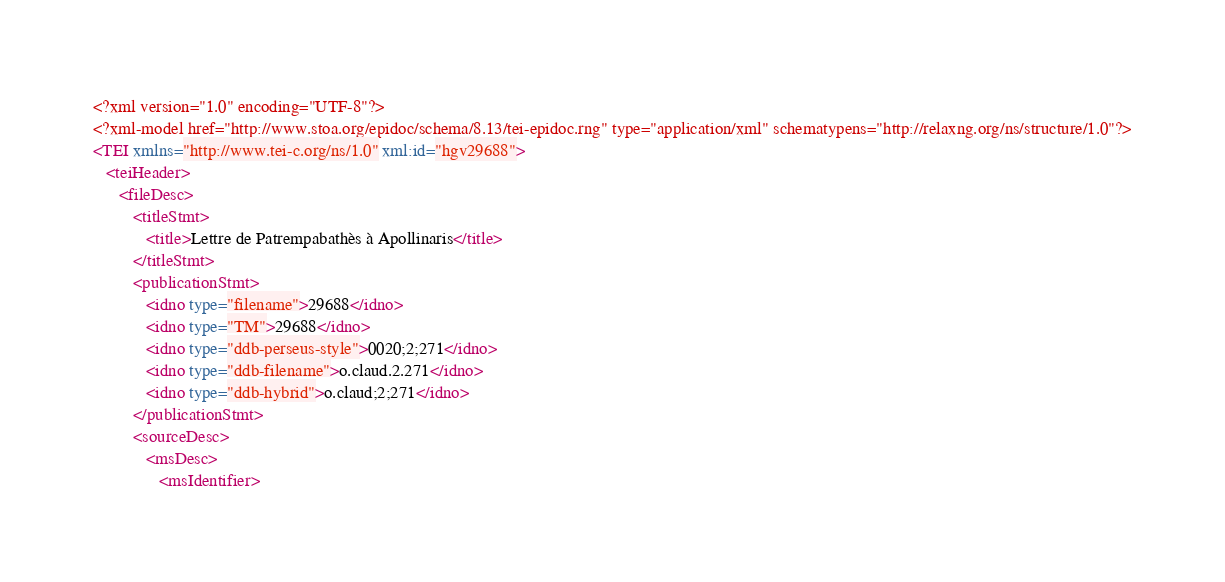Convert code to text. <code><loc_0><loc_0><loc_500><loc_500><_XML_><?xml version="1.0" encoding="UTF-8"?>
<?xml-model href="http://www.stoa.org/epidoc/schema/8.13/tei-epidoc.rng" type="application/xml" schematypens="http://relaxng.org/ns/structure/1.0"?>
<TEI xmlns="http://www.tei-c.org/ns/1.0" xml:id="hgv29688">
   <teiHeader>
      <fileDesc>
         <titleStmt>
            <title>Lettre de Patrempabathès à Apollinaris</title>
         </titleStmt>
         <publicationStmt>
            <idno type="filename">29688</idno>
            <idno type="TM">29688</idno>
            <idno type="ddb-perseus-style">0020;2;271</idno>
            <idno type="ddb-filename">o.claud.2.271</idno>
            <idno type="ddb-hybrid">o.claud;2;271</idno>
         </publicationStmt>
         <sourceDesc>
            <msDesc>
               <msIdentifier></code> 